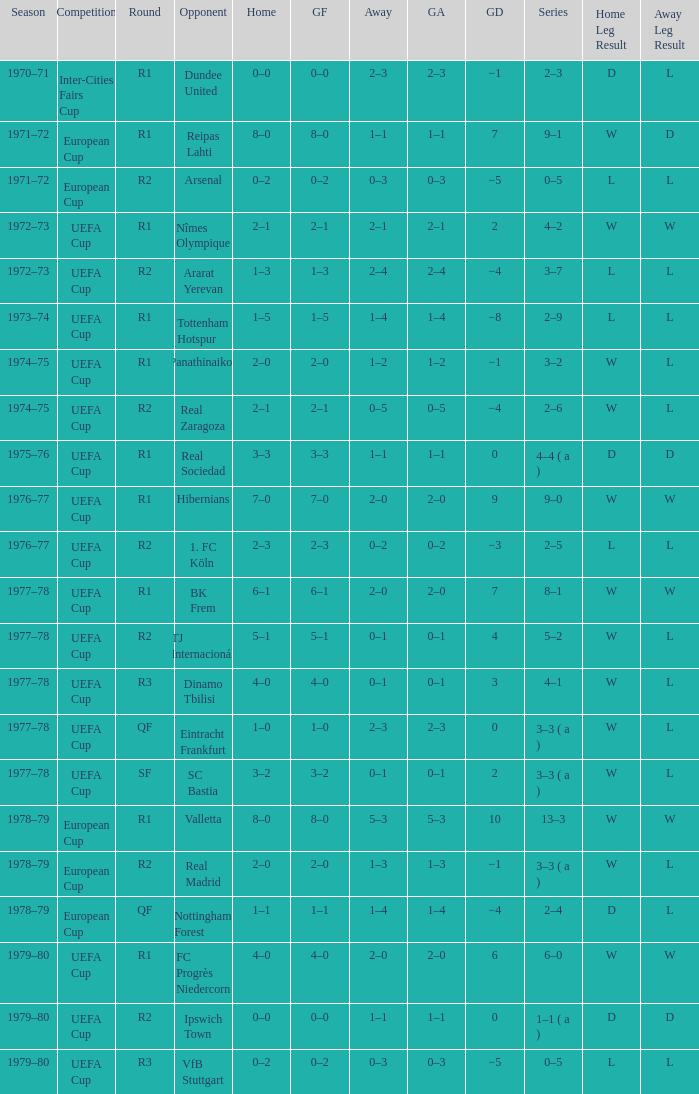Which Opponent has an Away of 1–1, and a Home of 3–3? Real Sociedad. Would you mind parsing the complete table? {'header': ['Season', 'Competition', 'Round', 'Opponent', 'Home', 'GF', 'Away', 'GA', 'GD', 'Series', 'Home Leg Result', 'Away Leg Result'], 'rows': [['1970–71', 'Inter-Cities Fairs Cup', 'R1', 'Dundee United', '0–0', '0–0', '2–3', '2–3', '−1', '2–3', 'D', 'L'], ['1971–72', 'European Cup', 'R1', 'Reipas Lahti', '8–0', '8–0', '1–1', '1–1', '7', '9–1', 'W', 'D'], ['1971–72', 'European Cup', 'R2', 'Arsenal', '0–2', '0–2', '0–3', '0–3', '−5', '0–5', 'L', 'L'], ['1972–73', 'UEFA Cup', 'R1', 'Nîmes Olympique', '2–1', '2–1', '2–1', '2–1', '2', '4–2', 'W', 'W'], ['1972–73', 'UEFA Cup', 'R2', 'Ararat Yerevan', '1–3', '1–3', '2–4', '2–4', '−4', '3–7', 'L', 'L'], ['1973–74', 'UEFA Cup', 'R1', 'Tottenham Hotspur', '1–5', '1–5', '1–4', '1–4', '−8', '2–9', 'L', 'L'], ['1974–75', 'UEFA Cup', 'R1', 'Panathinaikos', '2–0', '2–0', '1–2', '1–2', '−1', '3–2', 'W', 'L'], ['1974–75', 'UEFA Cup', 'R2', 'Real Zaragoza', '2–1', '2–1', '0–5', '0–5', '−4', '2–6', 'W', 'L'], ['1975–76', 'UEFA Cup', 'R1', 'Real Sociedad', '3–3', '3–3', '1–1', '1–1', '0', '4–4 ( a )', 'D', 'D'], ['1976–77', 'UEFA Cup', 'R1', 'Hibernians', '7–0', '7–0', '2–0', '2–0', '9', '9–0', 'W', 'W'], ['1976–77', 'UEFA Cup', 'R2', '1. FC Köln', '2–3', '2–3', '0–2', '0–2', '−3', '2–5', 'L', 'L'], ['1977–78', 'UEFA Cup', 'R1', 'BK Frem', '6–1', '6–1', '2–0', '2–0', '7', '8–1', 'W', 'W'], ['1977–78', 'UEFA Cup', 'R2', 'TJ Internacionál', '5–1', '5–1', '0–1', '0–1', '4', '5–2', 'W', 'L'], ['1977–78', 'UEFA Cup', 'R3', 'Dinamo Tbilisi', '4–0', '4–0', '0–1', '0–1', '3', '4–1', 'W', 'L'], ['1977–78', 'UEFA Cup', 'QF', 'Eintracht Frankfurt', '1–0', '1–0', '2–3', '2–3', '0', '3–3 ( a )', 'W', 'L'], ['1977–78', 'UEFA Cup', 'SF', 'SC Bastia', '3–2', '3–2', '0–1', '0–1', '2', '3–3 ( a )', 'W', 'L'], ['1978–79', 'European Cup', 'R1', 'Valletta', '8–0', '8–0', '5–3', '5–3', '10', '13–3', 'W', 'W'], ['1978–79', 'European Cup', 'R2', 'Real Madrid', '2–0', '2–0', '1–3', '1–3', '−1', '3–3 ( a )', 'W', 'L'], ['1978–79', 'European Cup', 'QF', 'Nottingham Forest', '1–1', '1–1', '1–4', '1–4', '−4', '2–4', 'D', 'L'], ['1979–80', 'UEFA Cup', 'R1', 'FC Progrès Niedercorn', '4–0', '4–0', '2–0', '2–0', '6', '6–0', 'W', 'W'], ['1979–80', 'UEFA Cup', 'R2', 'Ipswich Town', '0–0', '0–0', '1–1', '1–1', '0', '1–1 ( a )', 'D', 'D'], ['1979–80', 'UEFA Cup', 'R3', 'VfB Stuttgart', '0–2', '0–2', '0–3', '0–3', '−5', '0–5', 'L', 'L']]} 